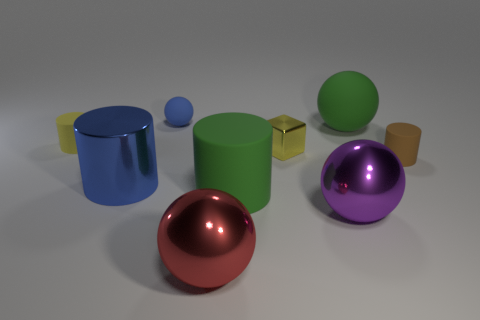What size is the yellow object right of the yellow cylinder behind the small brown thing?
Your response must be concise. Small. Are there an equal number of green rubber objects behind the green sphere and tiny brown matte things behind the tiny yellow shiny object?
Your answer should be compact. Yes. There is a big ball that is behind the green cylinder; are there any blue metallic objects in front of it?
Offer a terse response. Yes. The large green thing that is made of the same material as the green cylinder is what shape?
Your answer should be compact. Sphere. Is there any other thing that has the same color as the small matte sphere?
Give a very brief answer. Yes. What material is the small yellow object left of the big ball that is left of the purple shiny ball?
Keep it short and to the point. Rubber. Are there any large red metal objects that have the same shape as the tiny metal object?
Make the answer very short. No. What number of other things are there of the same shape as the brown thing?
Give a very brief answer. 3. There is a metal object that is in front of the tiny metal block and behind the big rubber cylinder; what shape is it?
Your answer should be compact. Cylinder. What is the size of the green rubber thing that is behind the brown matte thing?
Ensure brevity in your answer.  Large. 